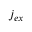Convert formula to latex. <formula><loc_0><loc_0><loc_500><loc_500>j _ { e x }</formula> 